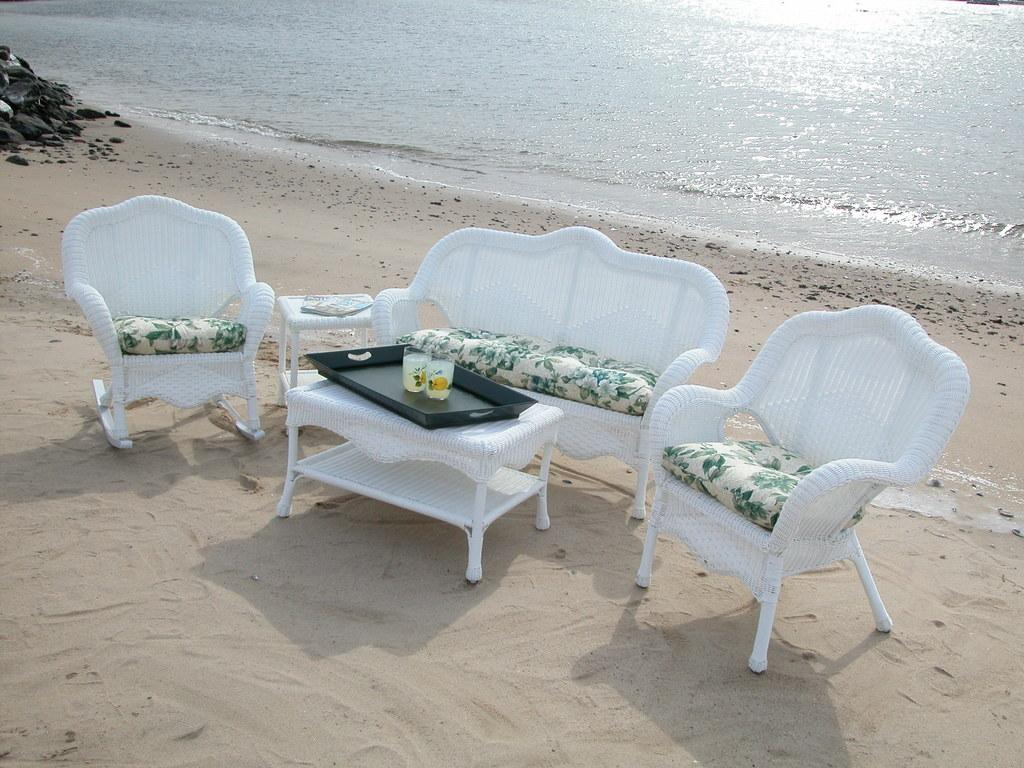Where is the sofa set placed in the image? The sofa set is placed on the sand in the image. What is the location of the sofa set in relation to the beach? The location of the sofa set is in front of a beach. What is present between the sofa set? There is a white table between the sofa set. What can be seen on the table? Two glasses are kept on a tray on the table? What is the condition of the toes of the person sitting on the sofa set? There is no person sitting on the sofa set in the image, so it is not possible to determine the condition of their toes. 